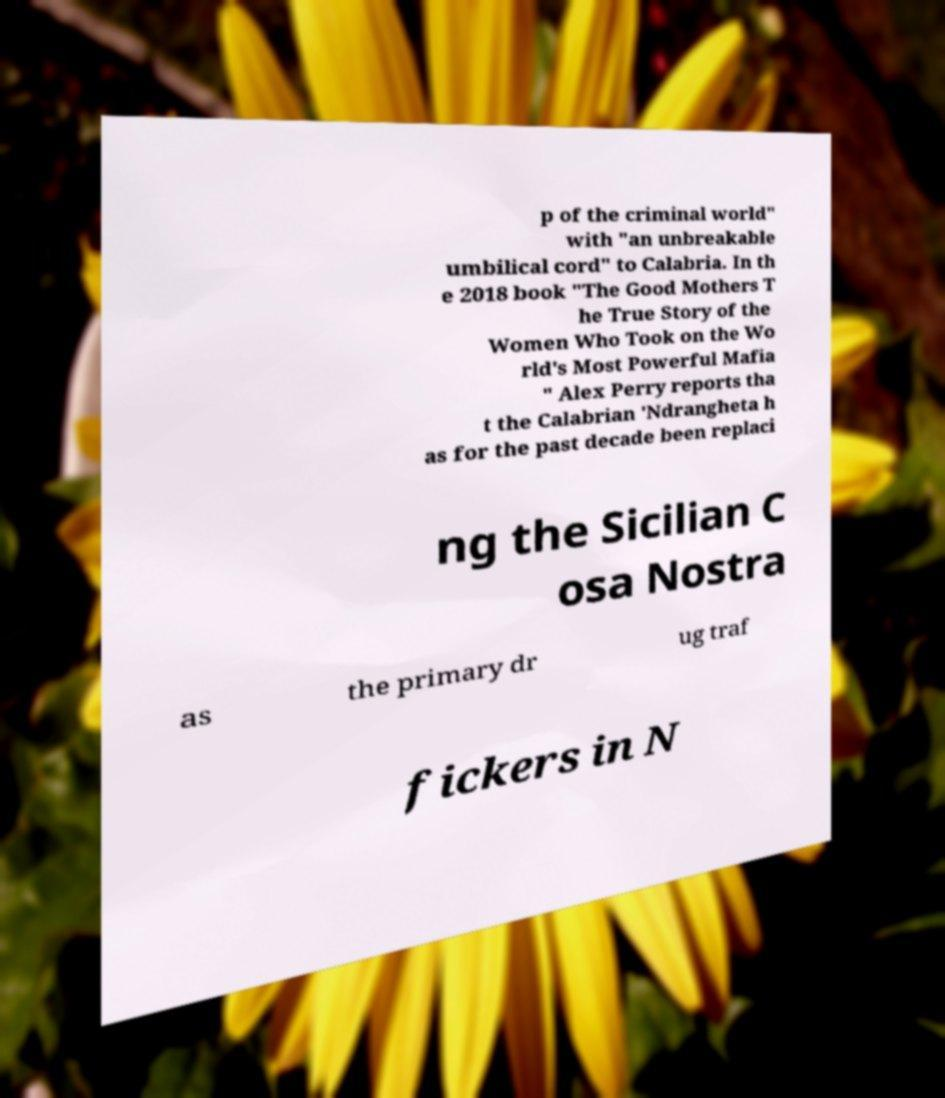Can you accurately transcribe the text from the provided image for me? p of the criminal world" with "an unbreakable umbilical cord" to Calabria. In th e 2018 book "The Good Mothers T he True Story of the Women Who Took on the Wo rld's Most Powerful Mafia " Alex Perry reports tha t the Calabrian 'Ndrangheta h as for the past decade been replaci ng the Sicilian C osa Nostra as the primary dr ug traf fickers in N 